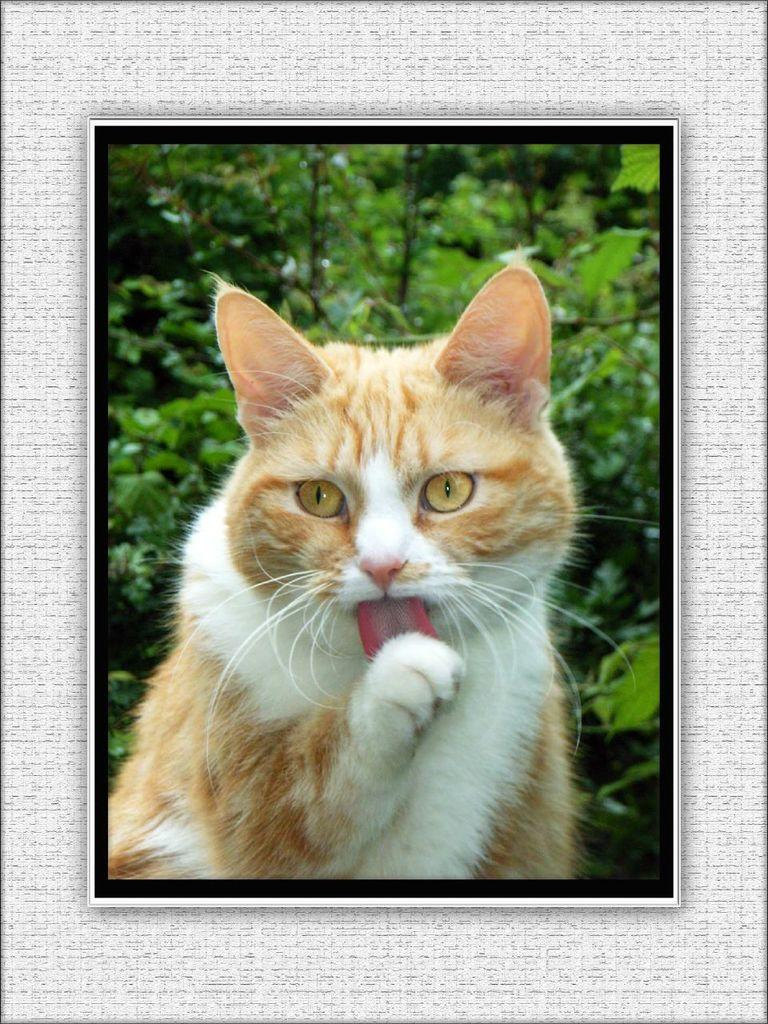What type of animal is present in the image? There is a cat in the image. What can be seen in the background of the image? There are a few leaves in the background of the image. How many mice are hiding under the cracker in the image? There are no mice or crackers present in the image. What type of basin is visible in the image? There is no basin present in the image. 